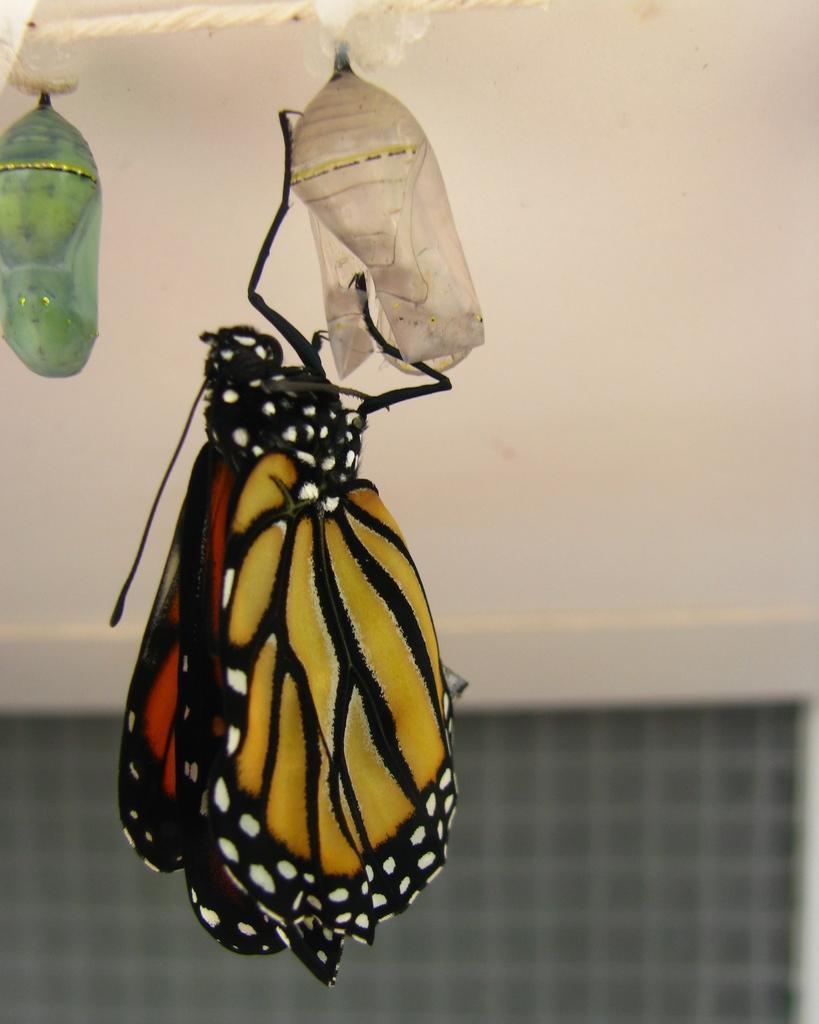In one or two sentences, can you explain what this image depicts? This image consists of a butterfly is hanging to an object. In the background, there is a wall. At the bottom, there is a window. 